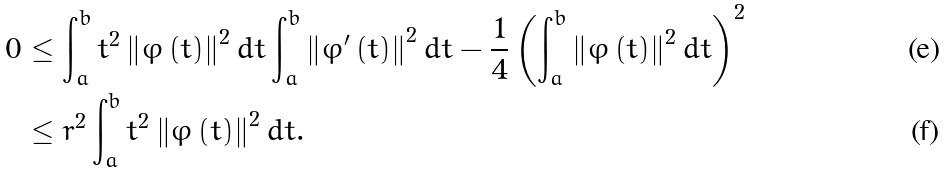<formula> <loc_0><loc_0><loc_500><loc_500>0 & \leq \int _ { a } ^ { b } t ^ { 2 } \left \| \varphi \left ( t \right ) \right \| ^ { 2 } d t \int _ { a } ^ { b } \left \| \varphi ^ { \prime } \left ( t \right ) \right \| ^ { 2 } d t - \frac { 1 } { 4 } \left ( \int _ { a } ^ { b } \left \| \varphi \left ( t \right ) \right \| ^ { 2 } d t \right ) ^ { 2 } \\ & \leq r ^ { 2 } \int _ { a } ^ { b } t ^ { 2 } \left \| \varphi \left ( t \right ) \right \| ^ { 2 } d t .</formula> 